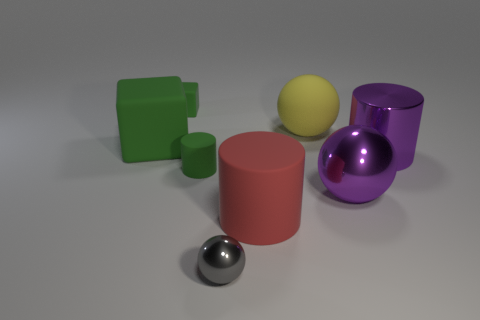What is the texture of the objects in the image? The objects in the image seem to have a smooth, matte texture, with the exception of the sphere on the right, which has a reflective, shiny surface. 